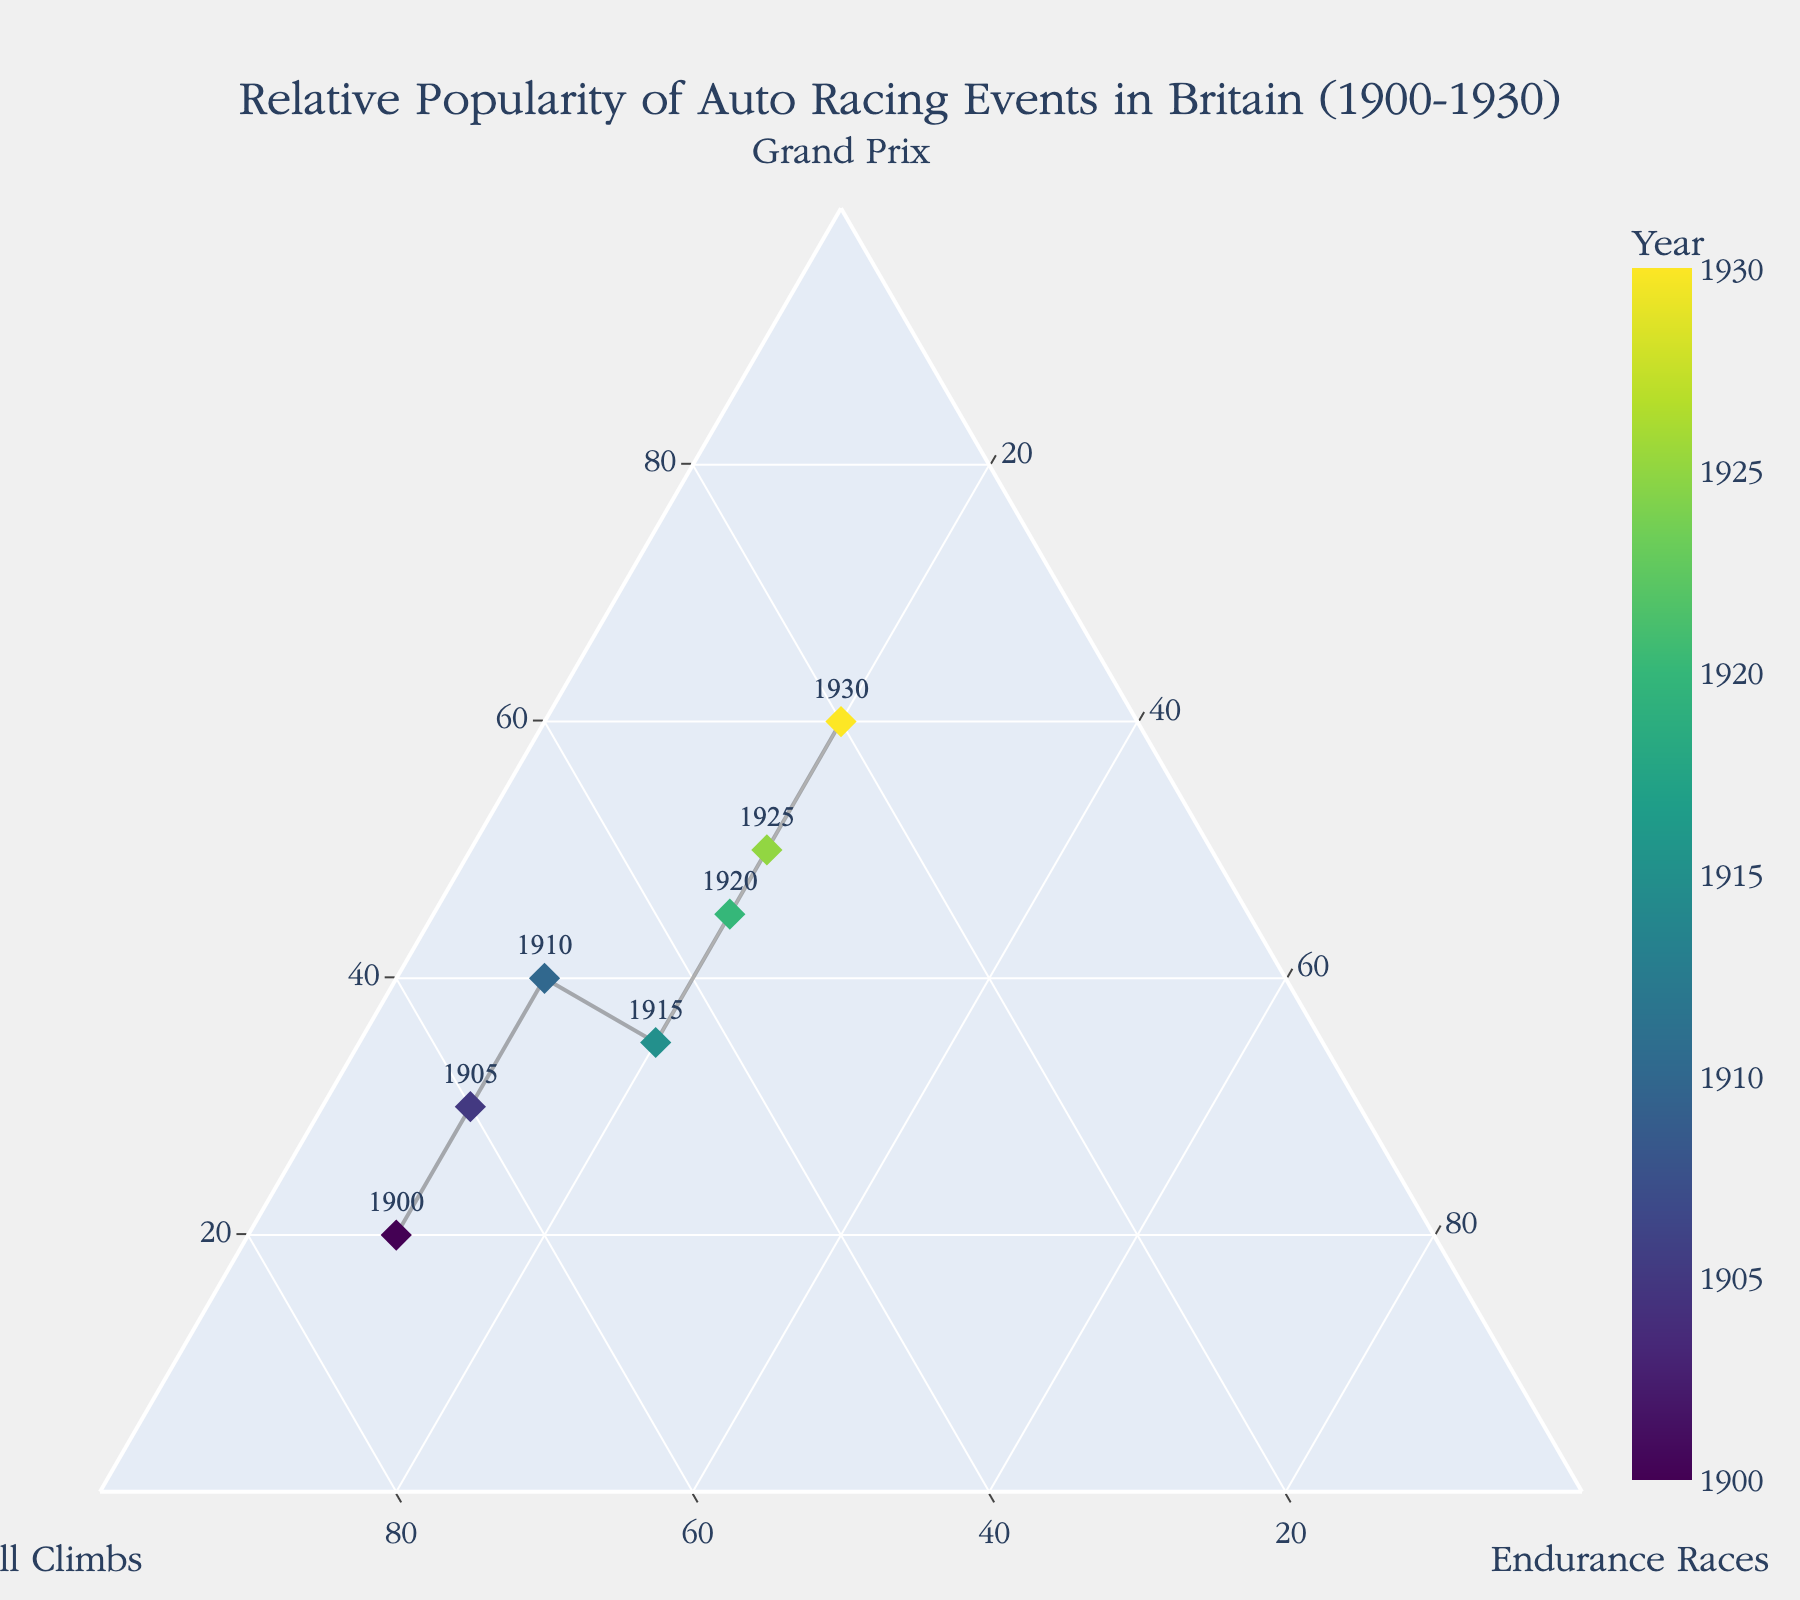What is the title of the plot? The title of the plot is located at the top of the figure. It reads "Relative Popularity of Auto Racing Events in Britain (1900-1930)."
Answer: Relative Popularity of Auto Racing Events in Britain (1900-1930) Which racing event was the most popular in 1900? To determine the most popular racing event in 1900, observe the data points closest to the vertices labeled for different races. For 1900, the data point leans heavily towards Hill Climbs.
Answer: Hill Climbs By how much did the popularity of Grand Prix events increase from 1900 to 1930? To find the increase, compare the percentages of Grand Prix in 1900 and 1930. In 1900, Grand Prix had a 20% share, and in 1930, it increased to 60%. The increase is 60% - 20%.
Answer: 40% What trend do you observe in the popularity of Hill Climbs over time? Observe the positions of the data points for each year. The points for Hill Climbs shift from being a dominant percentage (70% in 1900) to a much smaller percentage (20% in 1930), indicating a decline over time.
Answer: Declining Which year had the highest combined popularity of Endurance Races and Grand Prix events? To find this, add the percentages of Endurance Races and Grand Prix for each year. The year with the highest sum of these two percentages is 1930 (60% for Grand Prix and 20% for Endurance Races, totaling 80%).
Answer: 1930 Between 1920 and 1930, which event saw the most significant increase in popularity? Compare the percentages for the three events between these years. Endurance Races remained constant (20%), Hill Climbs decreased, but Grand Prix increased from 45% to 60%. Thus, Grand Prix had the most significant increase.
Answer: Grand Prix Is there a year where Hill Climbs and Endurance Races were equally popular? Look for a data point where the Hill Climbs and Endurance Races percentages equal each other. In 1930, they both stand at 20%.
Answer: 1930 Which event had the smallest share in 1915, and what was it? Refer to the data point for 1915 and check the percentages for each event. Endurance Races had the smallest share with 20%.
Answer: Endurance Races (20%) How many years are represented in the plot? Count the unique data points indicated by the year labels in the plot. The years shown are 1900, 1905, 1910, 1915, 1920, 1925, and 1930, totaling 7 years.
Answer: 7 years 